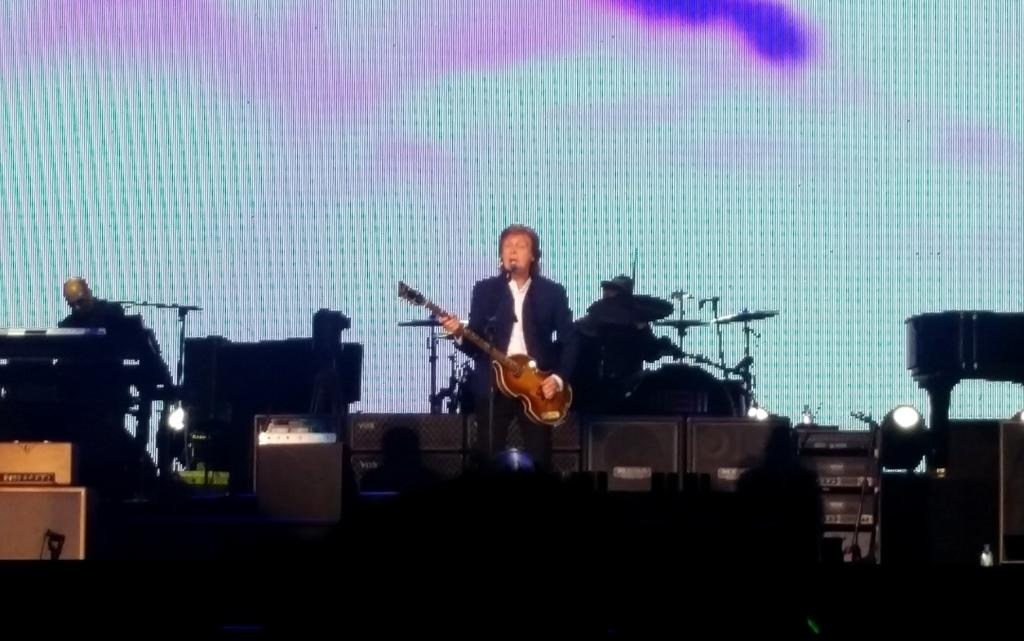How many musicians are performing on the stage in the image? There are three members playing musical instruments on the stage. What are the musicians doing in the image? They are playing musical instruments on the stage. What can be seen in the background of the image? There is a screen in the background. What channel is the sister watching at the camp in the image? There is no mention of a channel, sister, or camp in the image. The image features musicians playing instruments on a stage with a screen in the background. 